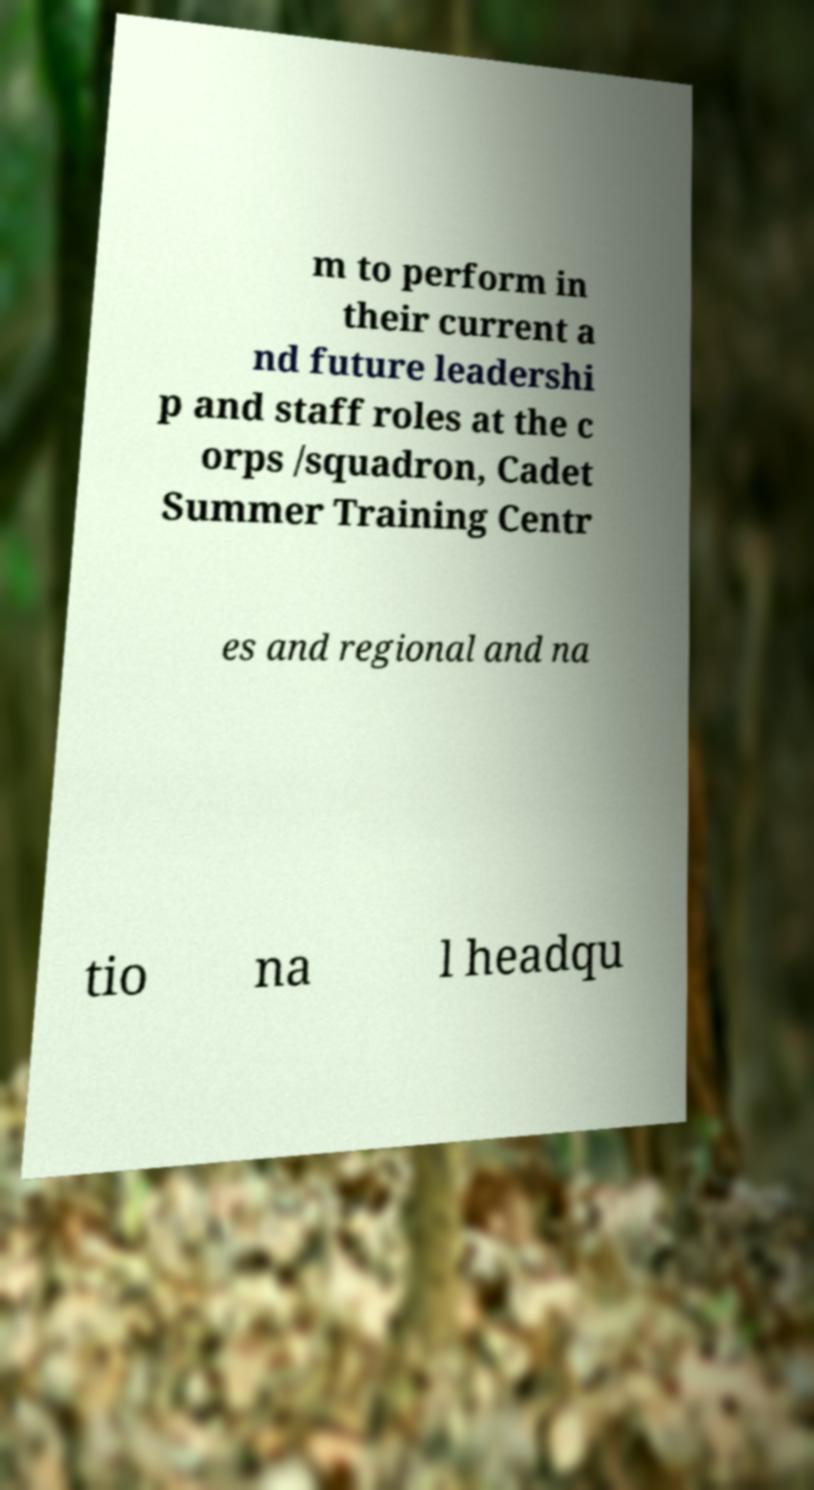I need the written content from this picture converted into text. Can you do that? m to perform in their current a nd future leadershi p and staff roles at the c orps /squadron, Cadet Summer Training Centr es and regional and na tio na l headqu 